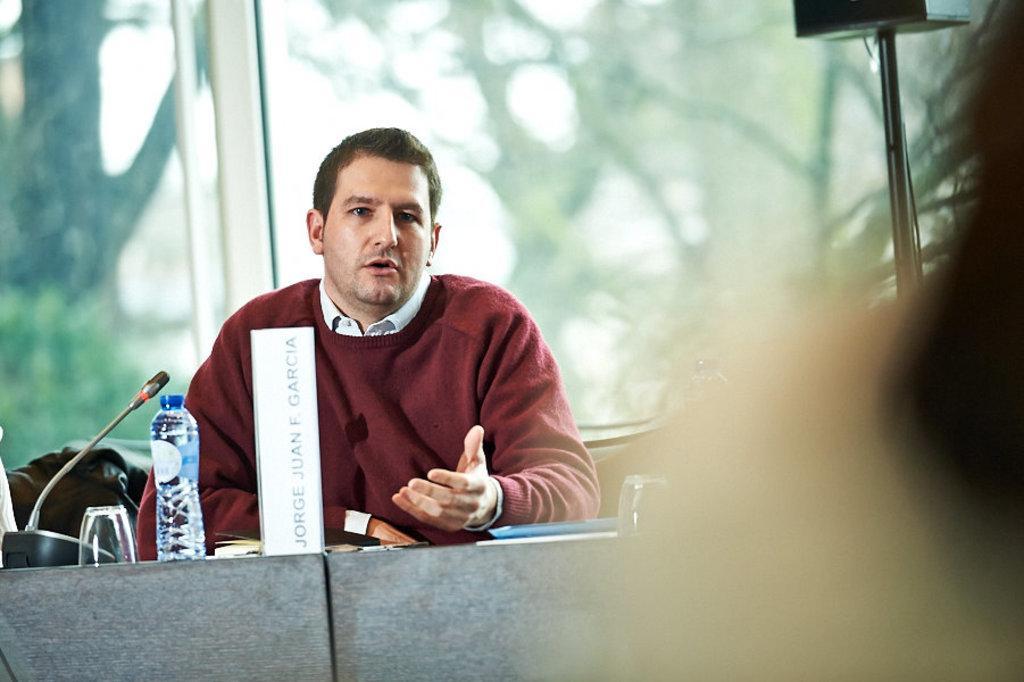Could you give a brief overview of what you see in this image? In this image we can see a person sitting behind a table containing microphone, books, a board with some text and some glasses placed on it. On the right side of the image we can see a speaker on a stand. In the background, we can see some trees and sky. 